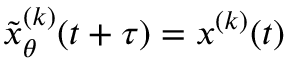Convert formula to latex. <formula><loc_0><loc_0><loc_500><loc_500>\tilde { x } _ { \theta } ^ { ( k ) } ( t + \tau ) = x ^ { ( k ) } ( t )</formula> 